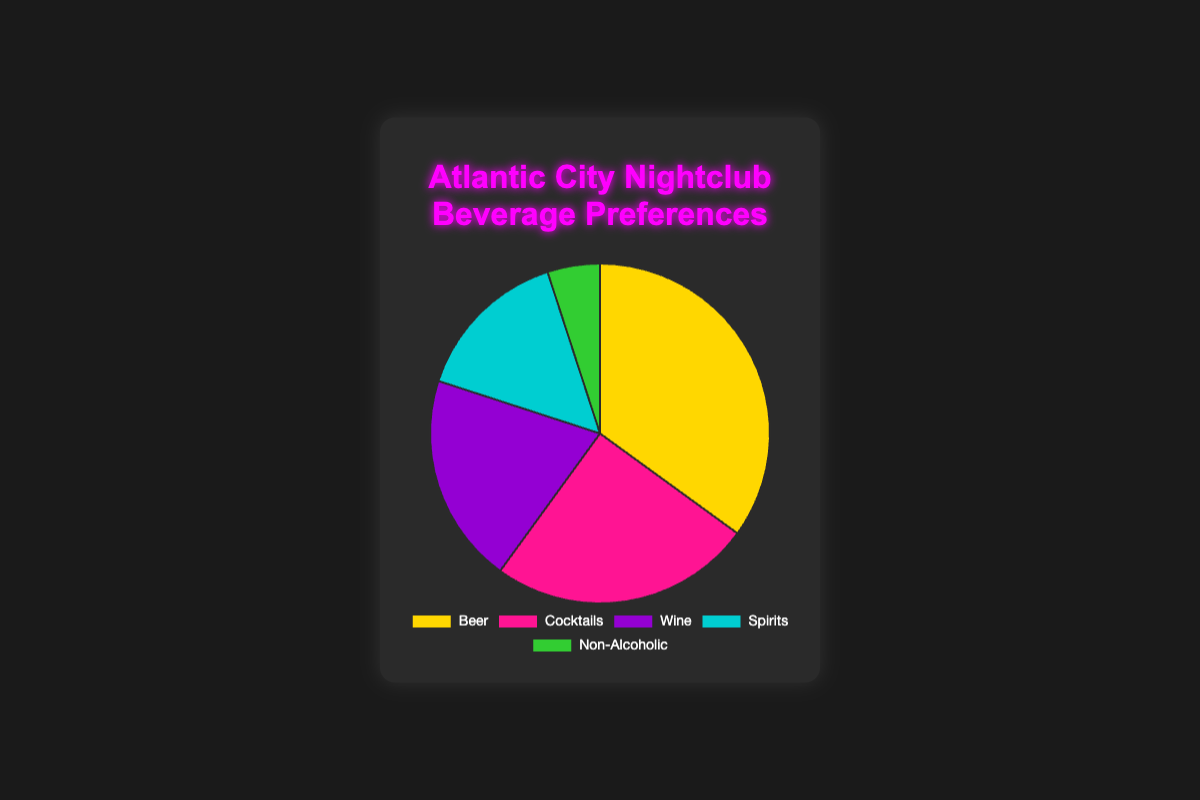Which beverage is the most preferred? The segment with the largest percentage indicates the most preferred beverage. Beer, with 35%, is the highest.
Answer: Beer Which beverage type has the smallest percentage? The smallest segment on the pie chart represents the least preferred beverage. Non-Alcoholic, at 5%, is the smallest.
Answer: Non-Alcoholic What is the combined preference percentage for Beer and Cocktails? Add the percentages of Beer and Cocktails: 35% + 25% = 60%.
Answer: 60% How much more preferred is Beer compared to Wine? Subtract Wine's percentage from Beer's: 35% - 20% = 15%.
Answer: 15% Which beverage types have a combined percentage equal to or less than the percentage of Beer? Identify beverage types whose sum does not exceed Beer's 35%. Non-Alcoholic and Spirits together have 5% + 15% = 20%, which is less than 35%.
Answer: Non-Alcoholic and Spirits What percentage of the preferences is for alcoholic beverages combined? Sum the percentages for Beer, Cocktails, Wine, and Spirits: 35% + 25% + 20% + 15% = 95%.
Answer: 95% Between Cocktails and Spirits, which is more popular and by how much? Compare their percentages; Cocktails (25%) is more popular than Spirits (15%) by 25% - 15% = 10%.
Answer: Cocktails by 10% Identify the beverage type represented by the purple segment. The colors assigned in the chart code indicate that "Wine" is represented by purple.
Answer: Wine List the beverages in order of preference based on the chart data. Arrange the beverages based on their percentages from highest to lowest: Beer (35%), Cocktails (25%), Wine (20%), Spirits (15%), Non-Alcoholic (5%).
Answer: Beer, Cocktails, Wine, Spirits, Non-Alcoholic What is the difference in percentage between the most and least preferred beverages? Subtract the percentage of the least preferred (Non-Alcoholic) from the most preferred (Beer): 35% - 5% = 30%.
Answer: 30% 